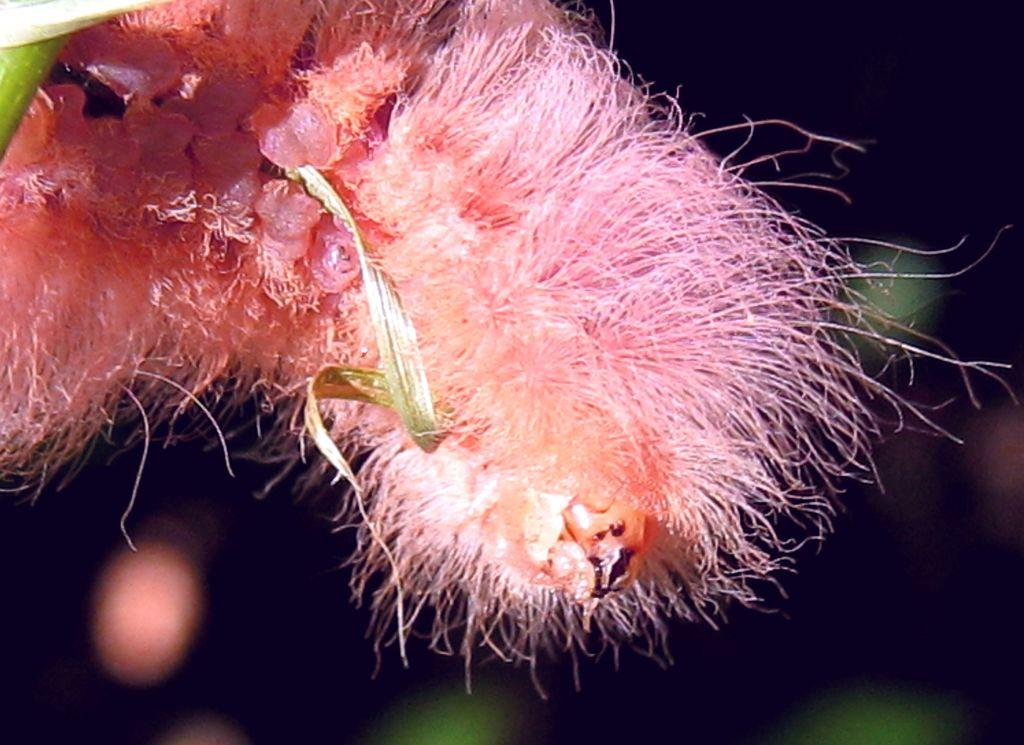What type of creature is present in the image? There is an insect in the image. How many cats are sitting on the fork with the dinosaurs in the image? There are no cats, forks, or dinosaurs present in the image; it only features an insect. 